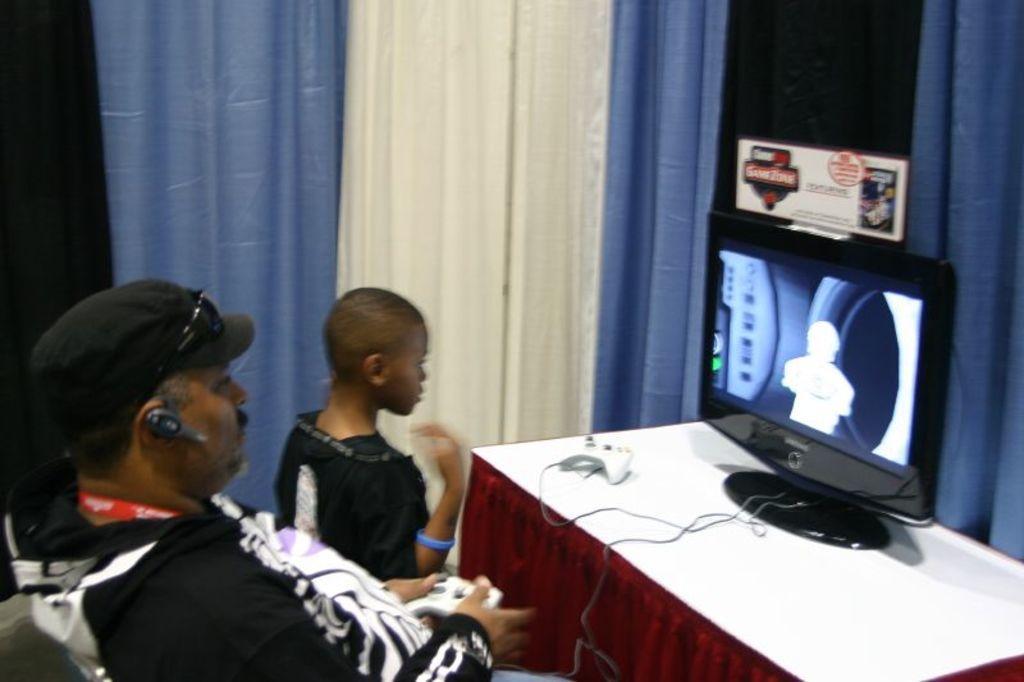Can you describe this image briefly? This person is standing and this person is sitting. This person wore cap, goggles and black jacket. On a table there is a monitor and remote. Curtains are in blue and white color. 